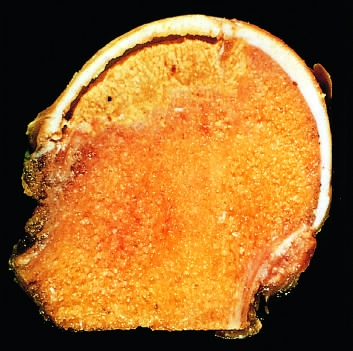s carcinomatous tissue caused by trabecular compression fractures without repair?
Answer the question using a single word or phrase. No 